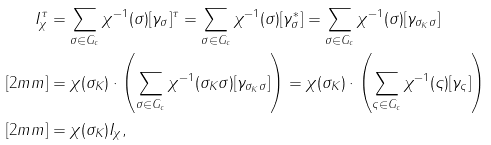Convert formula to latex. <formula><loc_0><loc_0><loc_500><loc_500>I _ { \chi } ^ { \tau } & = \sum _ { \sigma \in G _ { c } } \chi ^ { - 1 } ( \sigma ) [ \gamma _ { \sigma } ] ^ { \tau } = \sum _ { \sigma \in G _ { c } } \chi ^ { - 1 } ( \sigma ) [ \gamma _ { \sigma } ^ { \ast } ] = \sum _ { \sigma \in G _ { c } } \chi ^ { - 1 } ( \sigma ) [ \gamma _ { \sigma _ { K } \sigma } ] \\ [ 2 m m ] & = \chi ( \sigma _ { K } ) \cdot \left ( \sum _ { \sigma \in G _ { c } } \chi ^ { - 1 } ( \sigma _ { K } \sigma ) [ \gamma _ { \sigma _ { K } \sigma } ] \right ) = \chi ( \sigma _ { K } ) \cdot \left ( \sum _ { \varsigma \in G _ { c } } \chi ^ { - 1 } ( \varsigma ) [ \gamma _ { \varsigma } ] \right ) \\ [ 2 m m ] & = \chi ( \sigma _ { K } ) I _ { \chi } ,</formula> 